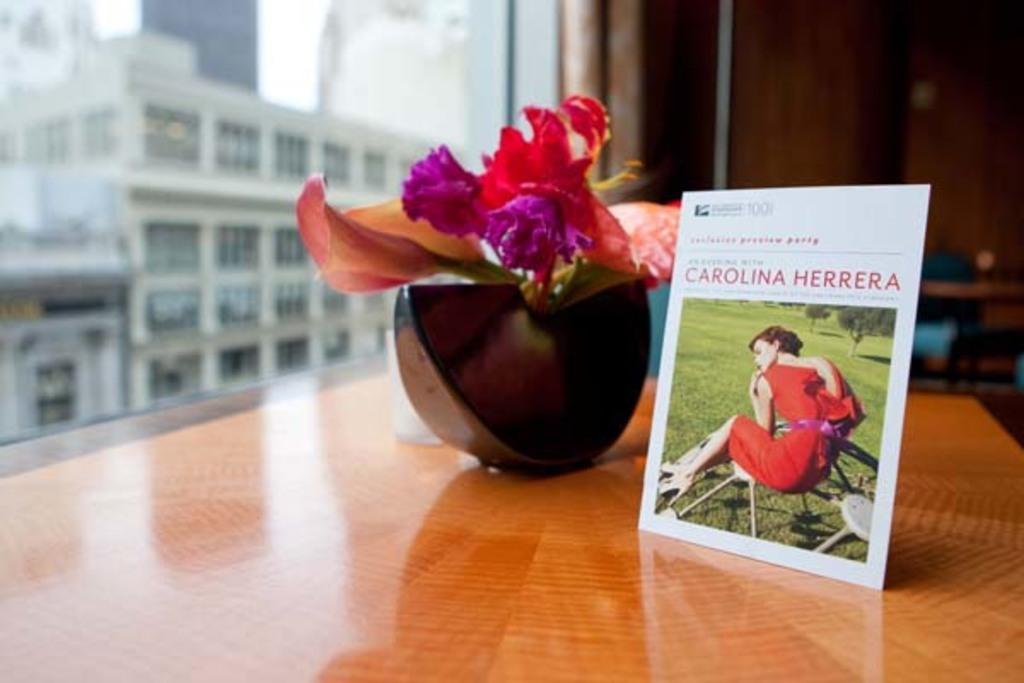What is the small structure in the image? There is a small hoarding in the image. What can be seen on a table in the image? There is a flower plant on a table in the image. What is visible through a window in the image? There is a building visible through a window in the image. What type of iron is being used to hold the flower plant in the image? There is no iron visible in the image, and the flower plant is not being held by any iron object. Can you see a harbor in the image? There is no harbor present in the image; the visible building is not a harbor. 